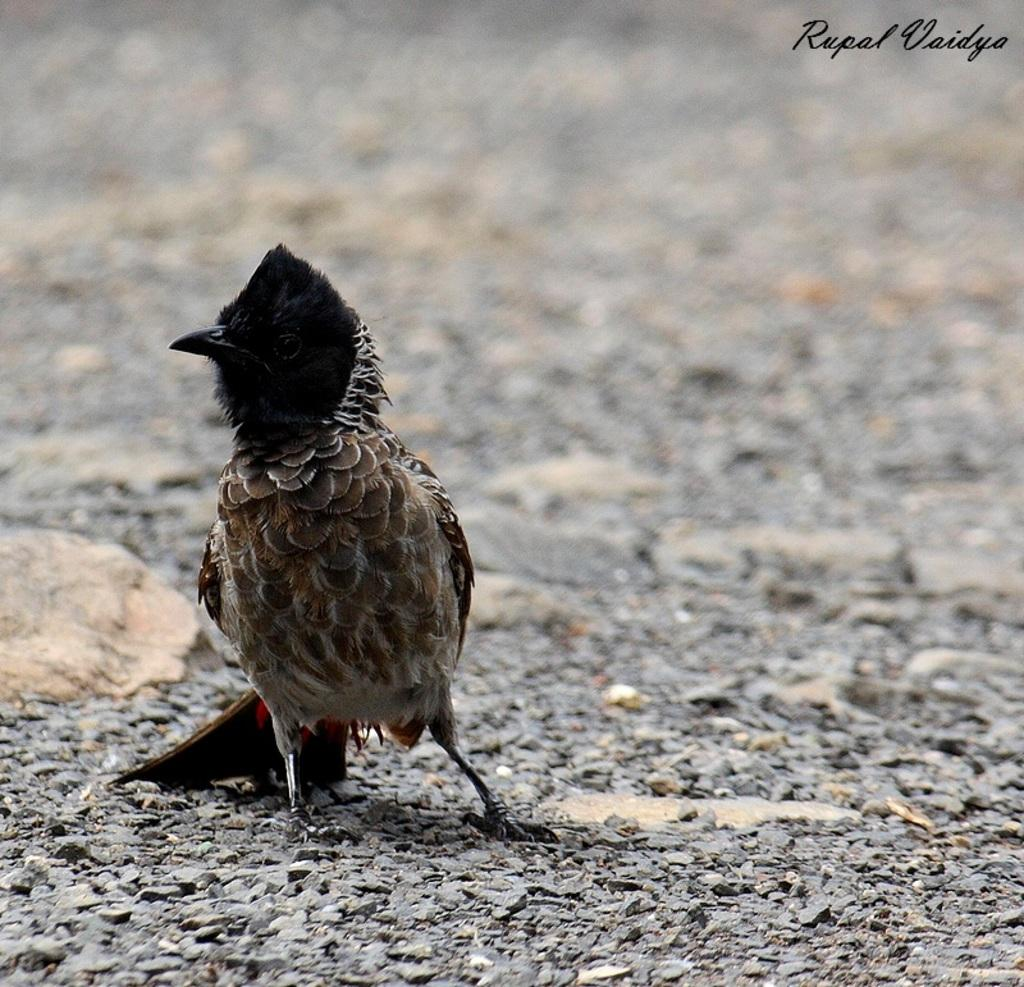What is the main subject of the image? There is a bird in the center of the image. Where is the bird located in the image? The bird is on the ground. Can you see the ocean or seashore in the image? No, there is no ocean or seashore visible in the image. What type of territory does the bird claim in the image? The image does not provide information about the bird's territory. 